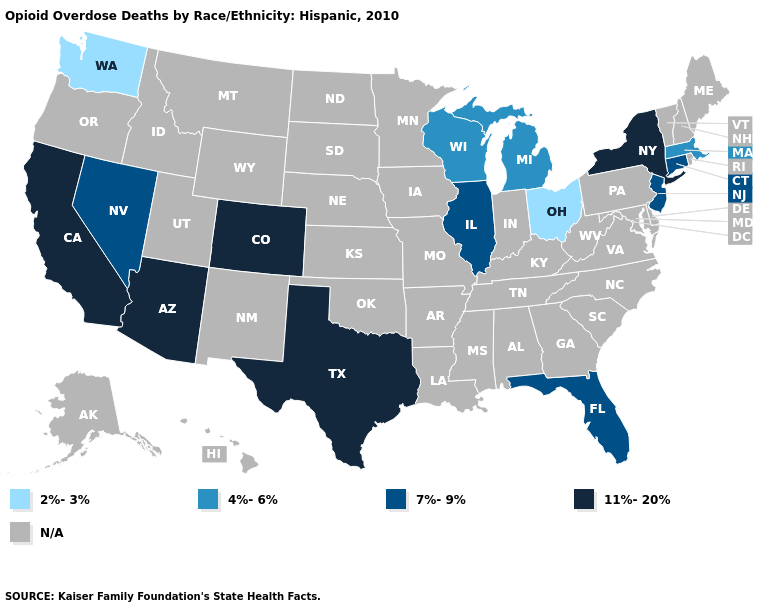What is the value of New York?
Keep it brief. 11%-20%. Name the states that have a value in the range 7%-9%?
Short answer required. Connecticut, Florida, Illinois, Nevada, New Jersey. Which states have the highest value in the USA?
Be succinct. Arizona, California, Colorado, New York, Texas. Which states have the lowest value in the USA?
Quick response, please. Ohio, Washington. What is the value of Missouri?
Concise answer only. N/A. Name the states that have a value in the range N/A?
Write a very short answer. Alabama, Alaska, Arkansas, Delaware, Georgia, Hawaii, Idaho, Indiana, Iowa, Kansas, Kentucky, Louisiana, Maine, Maryland, Minnesota, Mississippi, Missouri, Montana, Nebraska, New Hampshire, New Mexico, North Carolina, North Dakota, Oklahoma, Oregon, Pennsylvania, Rhode Island, South Carolina, South Dakota, Tennessee, Utah, Vermont, Virginia, West Virginia, Wyoming. Does New York have the lowest value in the Northeast?
Answer briefly. No. Does Arizona have the highest value in the USA?
Quick response, please. Yes. What is the highest value in the USA?
Keep it brief. 11%-20%. Name the states that have a value in the range N/A?
Keep it brief. Alabama, Alaska, Arkansas, Delaware, Georgia, Hawaii, Idaho, Indiana, Iowa, Kansas, Kentucky, Louisiana, Maine, Maryland, Minnesota, Mississippi, Missouri, Montana, Nebraska, New Hampshire, New Mexico, North Carolina, North Dakota, Oklahoma, Oregon, Pennsylvania, Rhode Island, South Carolina, South Dakota, Tennessee, Utah, Vermont, Virginia, West Virginia, Wyoming. Does the map have missing data?
Keep it brief. Yes. Does the first symbol in the legend represent the smallest category?
Quick response, please. Yes. What is the highest value in the West ?
Answer briefly. 11%-20%. 